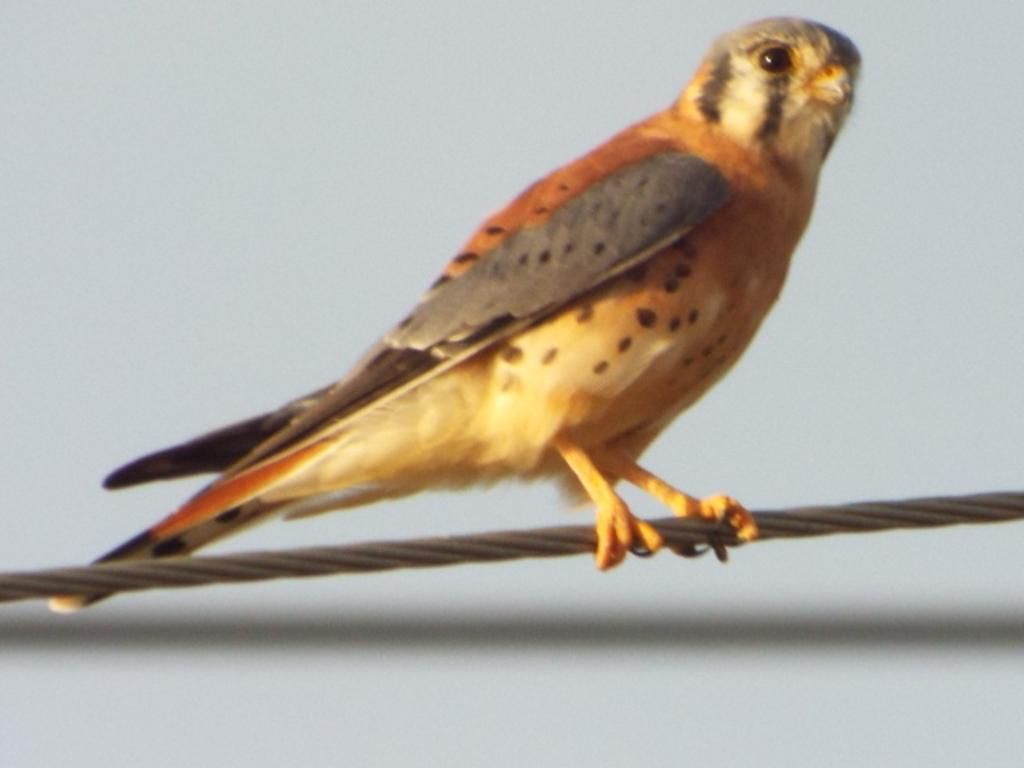In one or two sentences, can you explain what this image depicts? In this image I can see a bird which is ash, black, orange and white in color is standing on a wire and I can see the white background. 